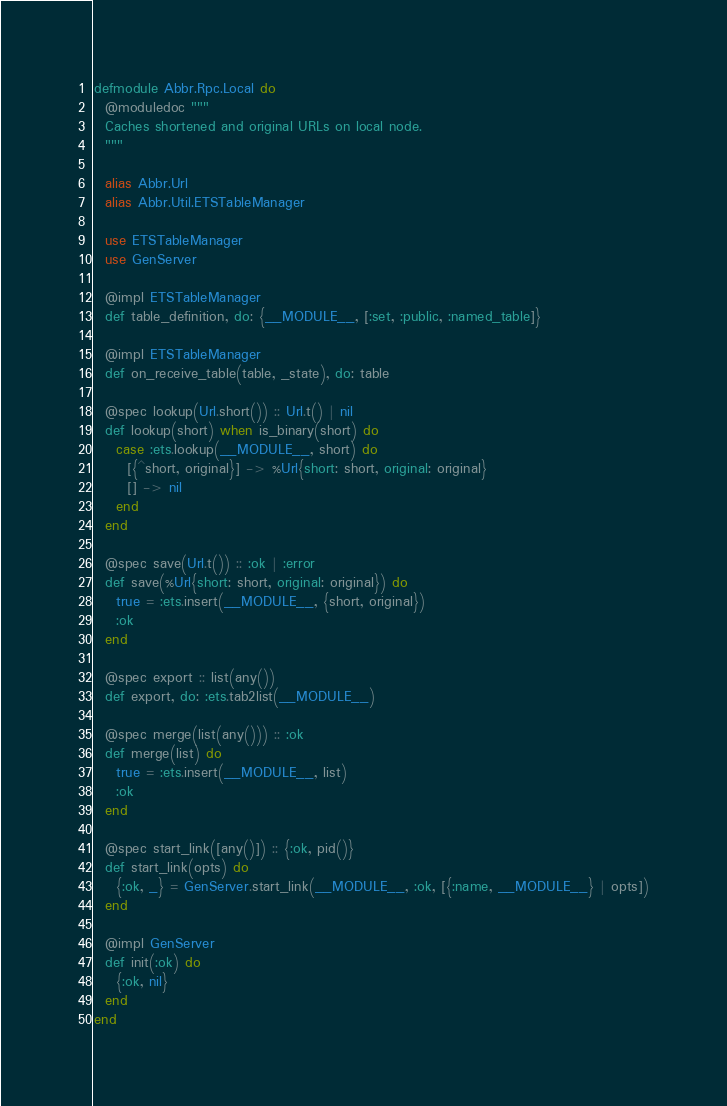<code> <loc_0><loc_0><loc_500><loc_500><_Elixir_>defmodule Abbr.Rpc.Local do
  @moduledoc """
  Caches shortened and original URLs on local node.
  """

  alias Abbr.Url
  alias Abbr.Util.ETSTableManager

  use ETSTableManager
  use GenServer

  @impl ETSTableManager
  def table_definition, do: {__MODULE__, [:set, :public, :named_table]}

  @impl ETSTableManager
  def on_receive_table(table, _state), do: table

  @spec lookup(Url.short()) :: Url.t() | nil
  def lookup(short) when is_binary(short) do
    case :ets.lookup(__MODULE__, short) do
      [{^short, original}] -> %Url{short: short, original: original}
      [] -> nil
    end
  end

  @spec save(Url.t()) :: :ok | :error
  def save(%Url{short: short, original: original}) do
    true = :ets.insert(__MODULE__, {short, original})
    :ok
  end

  @spec export :: list(any())
  def export, do: :ets.tab2list(__MODULE__)

  @spec merge(list(any())) :: :ok
  def merge(list) do
    true = :ets.insert(__MODULE__, list)
    :ok
  end

  @spec start_link([any()]) :: {:ok, pid()}
  def start_link(opts) do
    {:ok, _} = GenServer.start_link(__MODULE__, :ok, [{:name, __MODULE__} | opts])
  end

  @impl GenServer
  def init(:ok) do
    {:ok, nil}
  end
end
</code> 